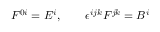<formula> <loc_0><loc_0><loc_500><loc_500>F ^ { 0 i } = E ^ { i } , \quad \epsilon ^ { i j k } F ^ { j k } = B ^ { i }</formula> 